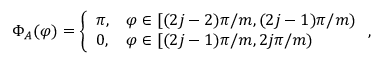<formula> <loc_0><loc_0><loc_500><loc_500>\Phi _ { A } ( \varphi ) = \left \{ \begin{array} { l l } { \pi , } & { \varphi \in [ ( 2 j - 2 ) \pi / m , ( 2 j - 1 ) \pi / m ) } \\ { 0 , } & { \varphi \in [ ( 2 j - 1 ) \pi / m , 2 j \pi / m ) } \end{array} ,</formula> 